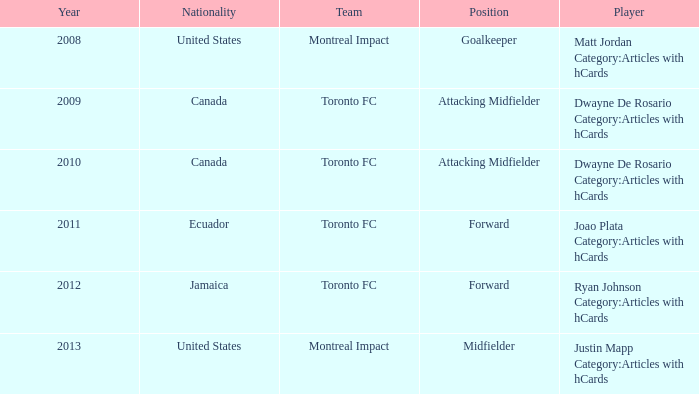What's the position when the player was Justin Mapp Category:articles with hcards with a United States nationality? Midfielder. 